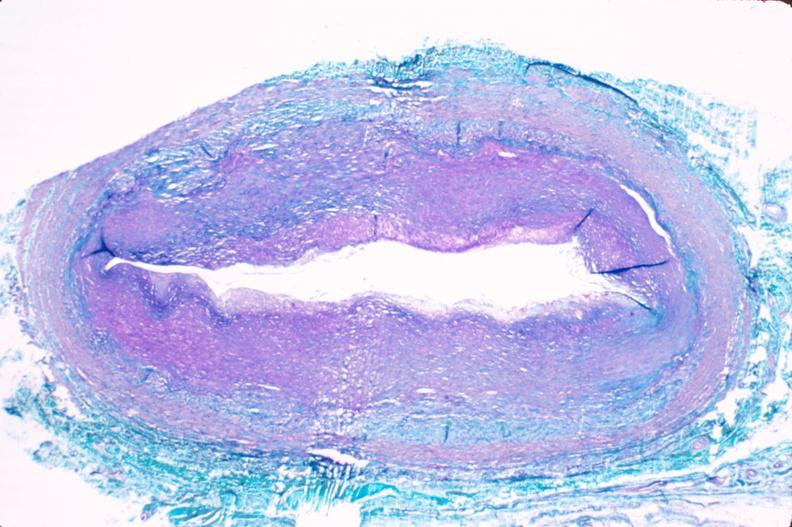s spina bifida present?
Answer the question using a single word or phrase. No 